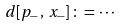Convert formula to latex. <formula><loc_0><loc_0><loc_500><loc_500>d [ p _ { - } \, , \, x _ { - } ] \, \colon = \, \cdots</formula> 